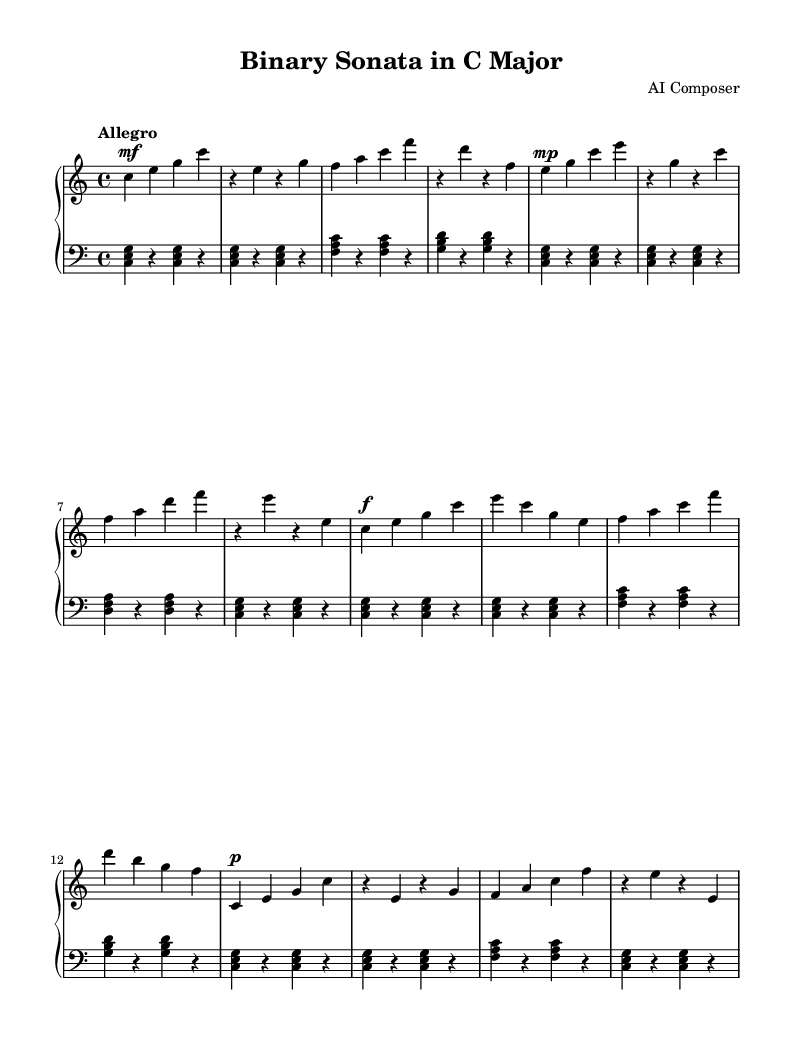What is the key signature of this music? The key signature is indicated at the beginning of the score with no sharps or flats, which confirms it is in C major.
Answer: C major What is the time signature of this music? The time signature is displayed at the beginning of the score; it shows 4/4, meaning there are four beats in each measure.
Answer: 4/4 What tempo marking is used in this piece? The tempo marking is found at the start of the score, stating "Allegro," indicating a fast and lively pace.
Answer: Allegro How many measures are in the Exposition section? By counting the measures displayed in the Exposition section of the right hand and left hand parts, there are a total of 8 measures.
Answer: 8 Which two chords are primarily used in the Exposition? Analyzing the left hand during the Exposition, the chords used are C major (C, E, G) and F major (F, A, C).
Answer: C major and F major In which section does the dynamic marking 'f' first appear? To find where 'f' (forte) first appears, one can scan through the right hand part; it is noted on the first measure of the Development section.
Answer: Development What rhythmic structure is evident in the left hand part? Examining the left hand, it shows a consistent rhythmic pattern of voicing triads followed by rests, heavily resembling binary sequences with long and short notes.
Answer: Triads with rests 